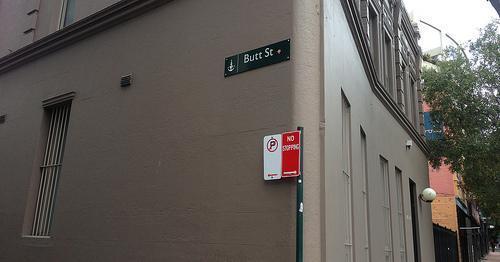How many stories does the main building have?
Give a very brief answer. 2. 